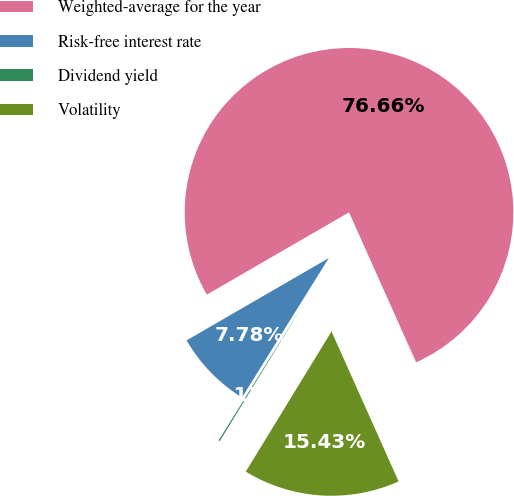<chart> <loc_0><loc_0><loc_500><loc_500><pie_chart><fcel>Weighted-average for the year<fcel>Risk-free interest rate<fcel>Dividend yield<fcel>Volatility<nl><fcel>76.65%<fcel>7.78%<fcel>0.13%<fcel>15.43%<nl></chart> 